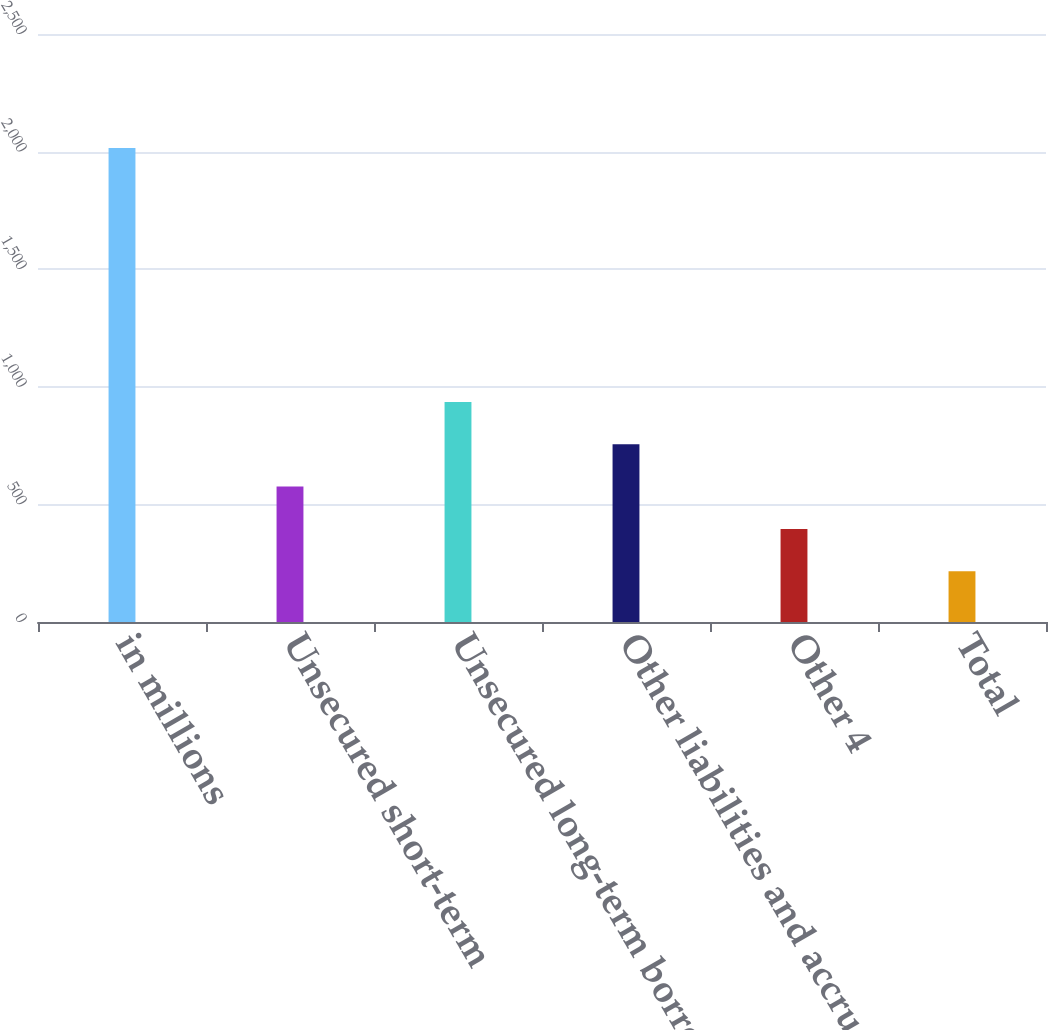Convert chart. <chart><loc_0><loc_0><loc_500><loc_500><bar_chart><fcel>in millions<fcel>Unsecured short-term<fcel>Unsecured long-term borrowings<fcel>Other liabilities and accrued<fcel>Other 4<fcel>Total<nl><fcel>2015<fcel>575.8<fcel>935.6<fcel>755.7<fcel>395.9<fcel>216<nl></chart> 